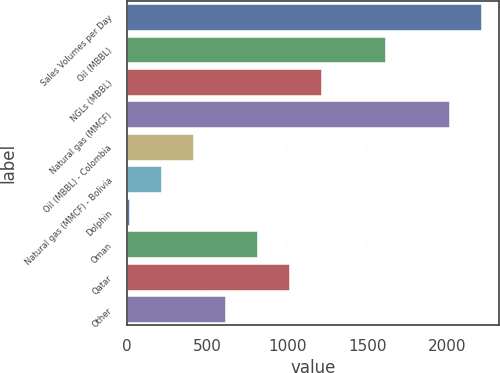Convert chart to OTSL. <chart><loc_0><loc_0><loc_500><loc_500><bar_chart><fcel>Sales Volumes per Day<fcel>Oil (MBBL)<fcel>NGLs (MBBL)<fcel>Natural gas (MMCF)<fcel>Oil (MBBL) - Colombia<fcel>Natural gas (MMCF) - Bolivia<fcel>Dolphin<fcel>Oman<fcel>Qatar<fcel>Other<nl><fcel>2212.4<fcel>1611.2<fcel>1210.4<fcel>2012<fcel>408.8<fcel>208.4<fcel>8<fcel>809.6<fcel>1010<fcel>609.2<nl></chart> 